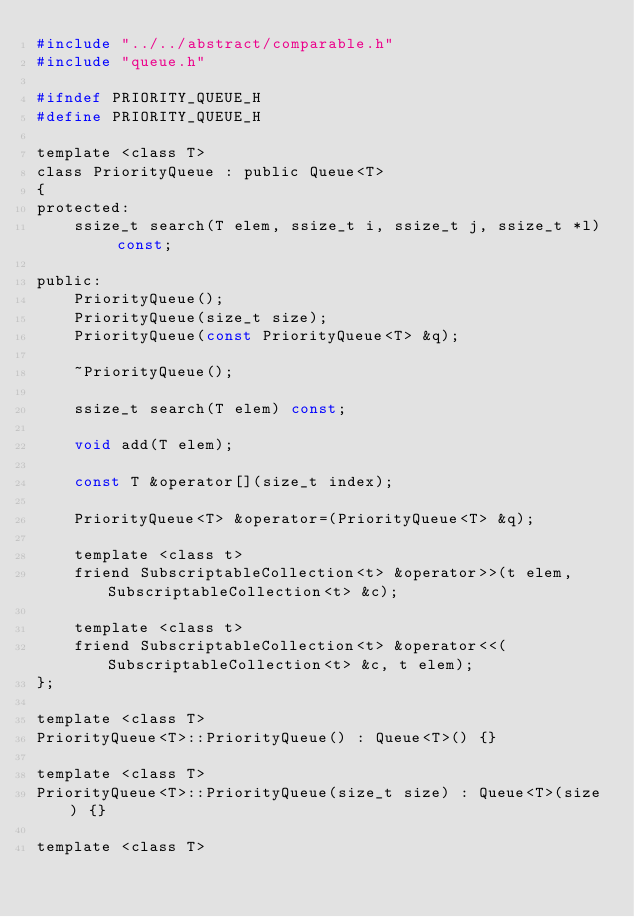<code> <loc_0><loc_0><loc_500><loc_500><_C_>#include "../../abstract/comparable.h"
#include "queue.h"

#ifndef PRIORITY_QUEUE_H
#define PRIORITY_QUEUE_H

template <class T>
class PriorityQueue : public Queue<T>
{
protected:
    ssize_t search(T elem, ssize_t i, ssize_t j, ssize_t *l) const;

public:
    PriorityQueue();
    PriorityQueue(size_t size);
    PriorityQueue(const PriorityQueue<T> &q);

    ~PriorityQueue();

    ssize_t search(T elem) const;

    void add(T elem);

    const T &operator[](size_t index);

    PriorityQueue<T> &operator=(PriorityQueue<T> &q);

    template <class t>
    friend SubscriptableCollection<t> &operator>>(t elem, SubscriptableCollection<t> &c);

    template <class t>
    friend SubscriptableCollection<t> &operator<<(SubscriptableCollection<t> &c, t elem);
};

template <class T>
PriorityQueue<T>::PriorityQueue() : Queue<T>() {}

template <class T>
PriorityQueue<T>::PriorityQueue(size_t size) : Queue<T>(size) {}

template <class T></code> 